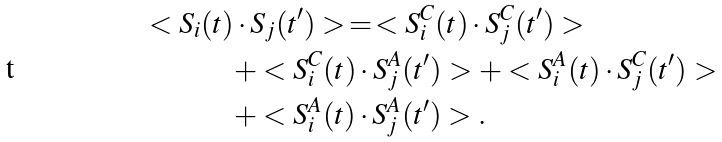Convert formula to latex. <formula><loc_0><loc_0><loc_500><loc_500>< S _ { i } ( t ) & \cdot S _ { j } ( t ^ { \prime } ) > \, = \, < S _ { i } ^ { C } ( t ) \cdot S _ { j } ^ { C } ( t ^ { \prime } ) > \\ & + < S _ { i } ^ { C } ( t ) \cdot S _ { j } ^ { A } ( t ^ { \prime } ) > + < S _ { i } ^ { A } ( t ) \cdot S _ { j } ^ { C } ( t ^ { \prime } ) > \\ & + < S _ { i } ^ { A } ( t ) \cdot S _ { j } ^ { A } ( t ^ { \prime } ) > .</formula> 